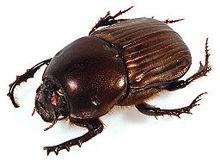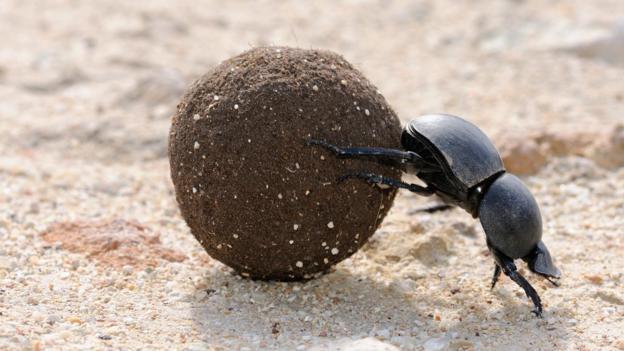The first image is the image on the left, the second image is the image on the right. Evaluate the accuracy of this statement regarding the images: "There are at least two beetles touching  a dungball.". Is it true? Answer yes or no. No. 